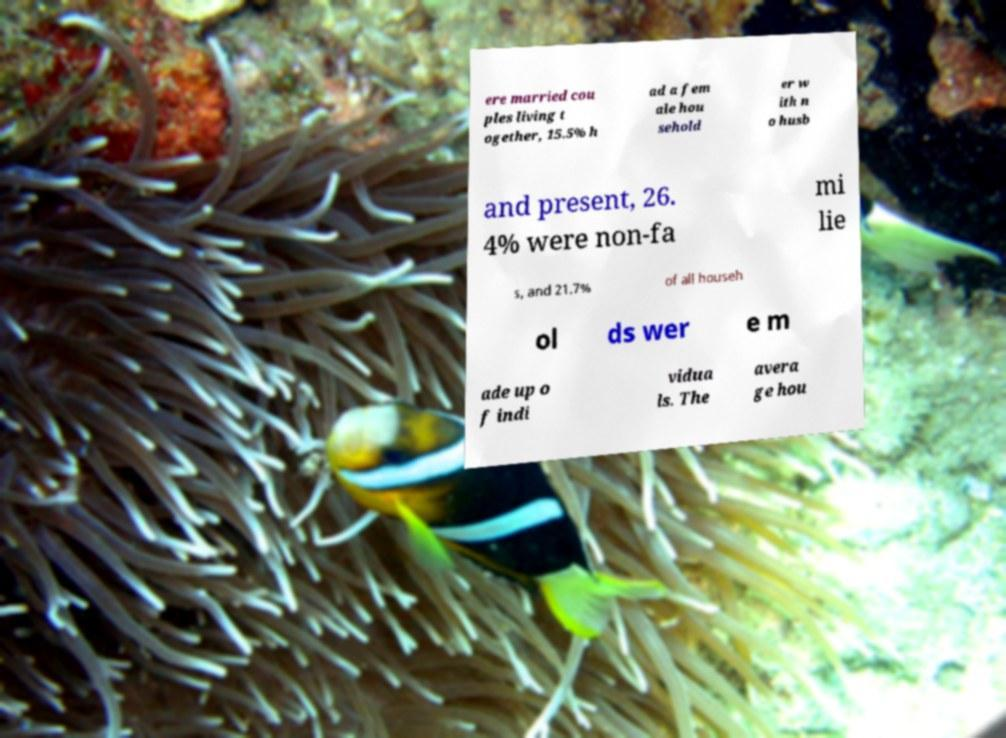There's text embedded in this image that I need extracted. Can you transcribe it verbatim? ere married cou ples living t ogether, 15.5% h ad a fem ale hou sehold er w ith n o husb and present, 26. 4% were non-fa mi lie s, and 21.7% of all househ ol ds wer e m ade up o f indi vidua ls. The avera ge hou 